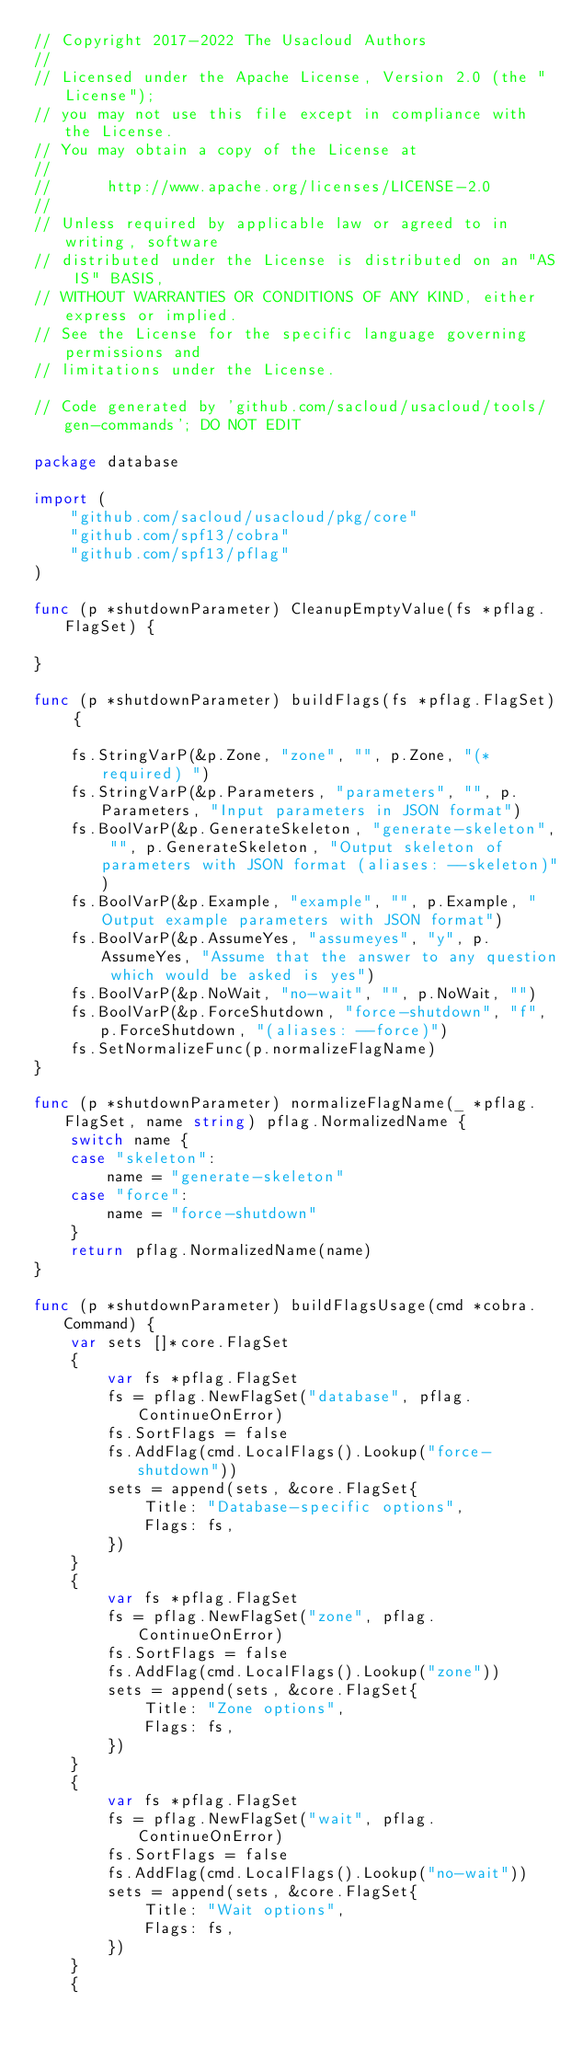<code> <loc_0><loc_0><loc_500><loc_500><_Go_>// Copyright 2017-2022 The Usacloud Authors
//
// Licensed under the Apache License, Version 2.0 (the "License");
// you may not use this file except in compliance with the License.
// You may obtain a copy of the License at
//
//      http://www.apache.org/licenses/LICENSE-2.0
//
// Unless required by applicable law or agreed to in writing, software
// distributed under the License is distributed on an "AS IS" BASIS,
// WITHOUT WARRANTIES OR CONDITIONS OF ANY KIND, either express or implied.
// See the License for the specific language governing permissions and
// limitations under the License.

// Code generated by 'github.com/sacloud/usacloud/tools/gen-commands'; DO NOT EDIT

package database

import (
	"github.com/sacloud/usacloud/pkg/core"
	"github.com/spf13/cobra"
	"github.com/spf13/pflag"
)

func (p *shutdownParameter) CleanupEmptyValue(fs *pflag.FlagSet) {

}

func (p *shutdownParameter) buildFlags(fs *pflag.FlagSet) {

	fs.StringVarP(&p.Zone, "zone", "", p.Zone, "(*required) ")
	fs.StringVarP(&p.Parameters, "parameters", "", p.Parameters, "Input parameters in JSON format")
	fs.BoolVarP(&p.GenerateSkeleton, "generate-skeleton", "", p.GenerateSkeleton, "Output skeleton of parameters with JSON format (aliases: --skeleton)")
	fs.BoolVarP(&p.Example, "example", "", p.Example, "Output example parameters with JSON format")
	fs.BoolVarP(&p.AssumeYes, "assumeyes", "y", p.AssumeYes, "Assume that the answer to any question which would be asked is yes")
	fs.BoolVarP(&p.NoWait, "no-wait", "", p.NoWait, "")
	fs.BoolVarP(&p.ForceShutdown, "force-shutdown", "f", p.ForceShutdown, "(aliases: --force)")
	fs.SetNormalizeFunc(p.normalizeFlagName)
}

func (p *shutdownParameter) normalizeFlagName(_ *pflag.FlagSet, name string) pflag.NormalizedName {
	switch name {
	case "skeleton":
		name = "generate-skeleton"
	case "force":
		name = "force-shutdown"
	}
	return pflag.NormalizedName(name)
}

func (p *shutdownParameter) buildFlagsUsage(cmd *cobra.Command) {
	var sets []*core.FlagSet
	{
		var fs *pflag.FlagSet
		fs = pflag.NewFlagSet("database", pflag.ContinueOnError)
		fs.SortFlags = false
		fs.AddFlag(cmd.LocalFlags().Lookup("force-shutdown"))
		sets = append(sets, &core.FlagSet{
			Title: "Database-specific options",
			Flags: fs,
		})
	}
	{
		var fs *pflag.FlagSet
		fs = pflag.NewFlagSet("zone", pflag.ContinueOnError)
		fs.SortFlags = false
		fs.AddFlag(cmd.LocalFlags().Lookup("zone"))
		sets = append(sets, &core.FlagSet{
			Title: "Zone options",
			Flags: fs,
		})
	}
	{
		var fs *pflag.FlagSet
		fs = pflag.NewFlagSet("wait", pflag.ContinueOnError)
		fs.SortFlags = false
		fs.AddFlag(cmd.LocalFlags().Lookup("no-wait"))
		sets = append(sets, &core.FlagSet{
			Title: "Wait options",
			Flags: fs,
		})
	}
	{</code> 